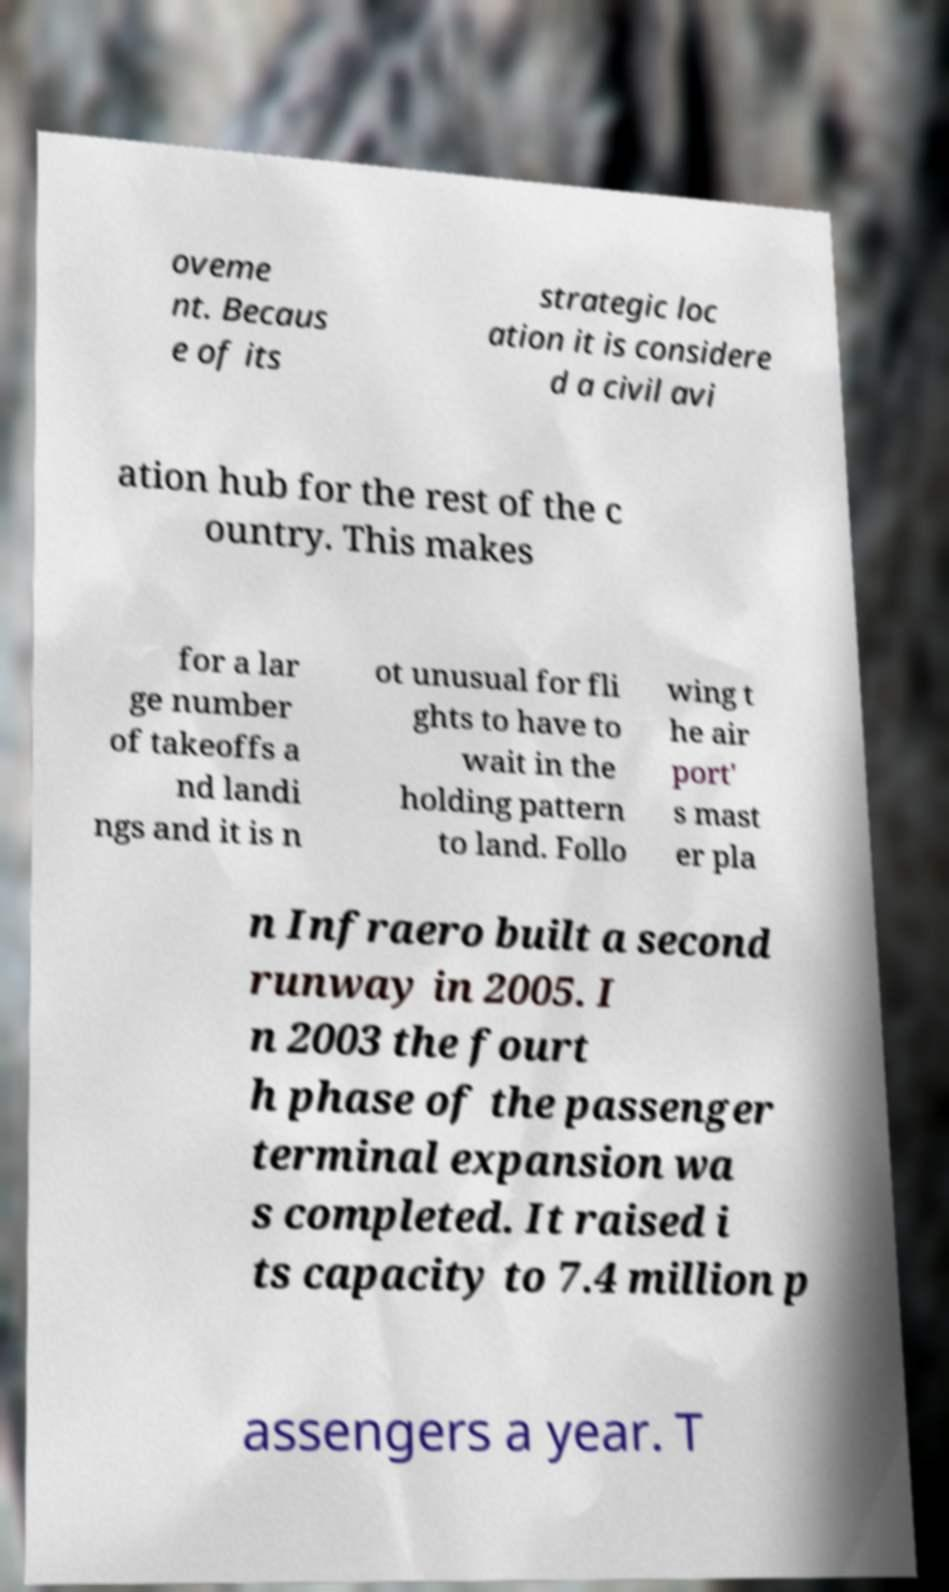Can you accurately transcribe the text from the provided image for me? oveme nt. Becaus e of its strategic loc ation it is considere d a civil avi ation hub for the rest of the c ountry. This makes for a lar ge number of takeoffs a nd landi ngs and it is n ot unusual for fli ghts to have to wait in the holding pattern to land. Follo wing t he air port' s mast er pla n Infraero built a second runway in 2005. I n 2003 the fourt h phase of the passenger terminal expansion wa s completed. It raised i ts capacity to 7.4 million p assengers a year. T 